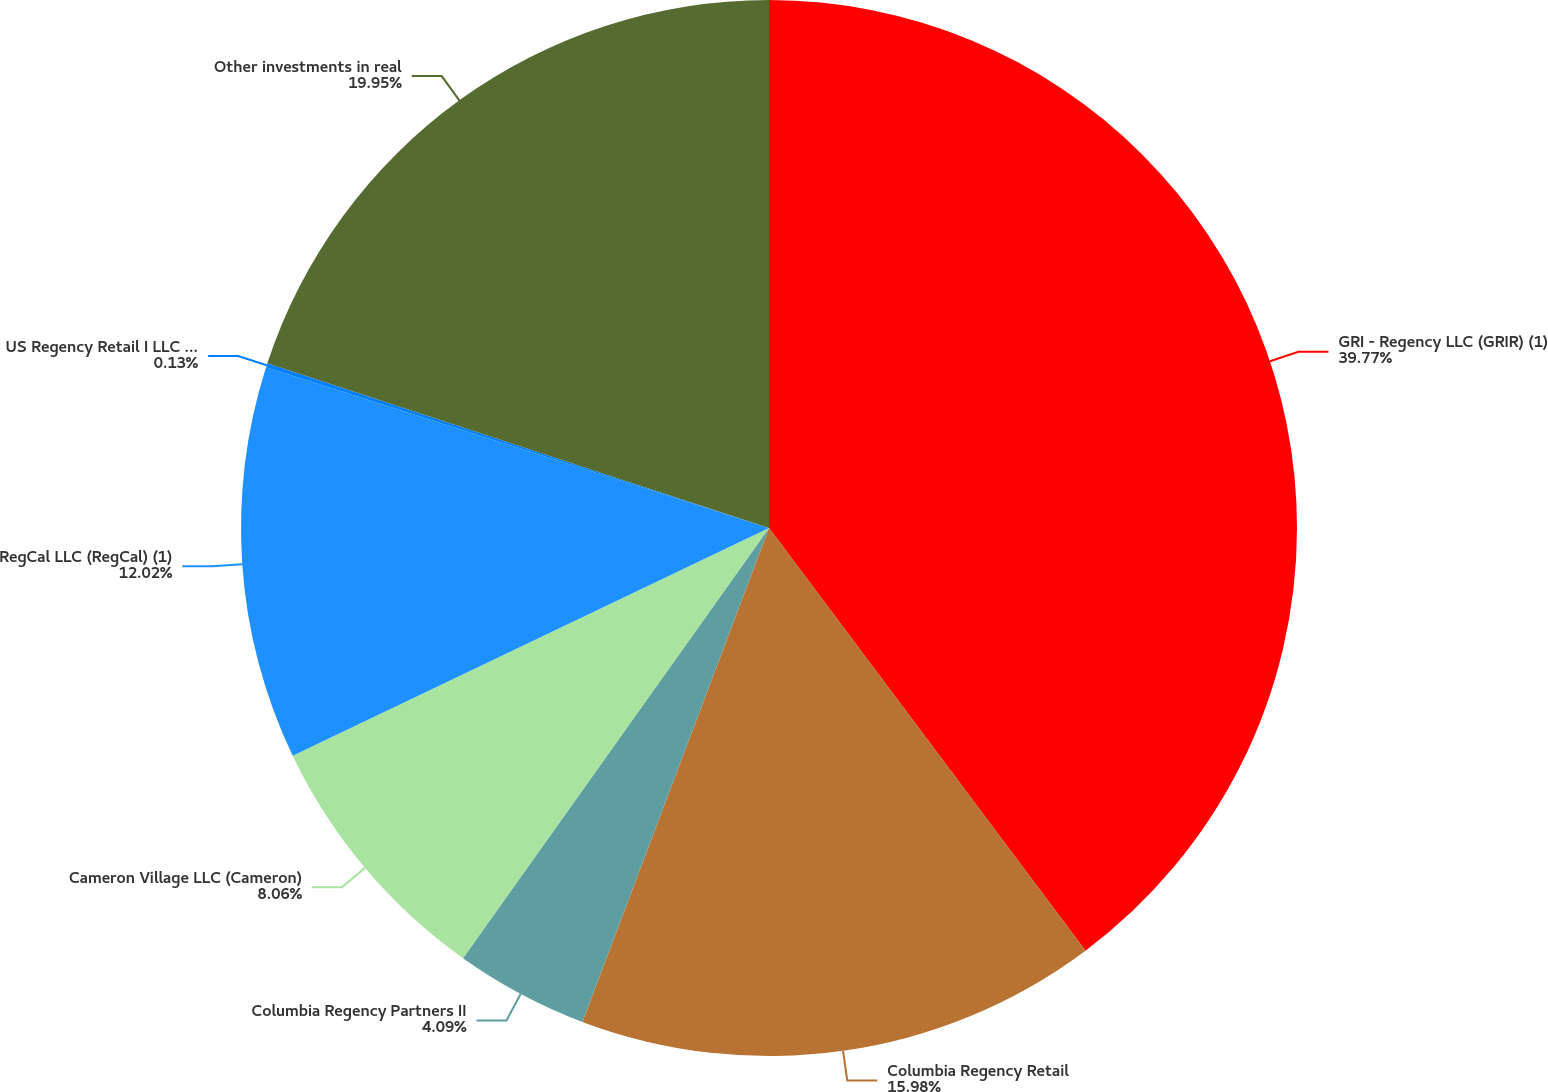Convert chart. <chart><loc_0><loc_0><loc_500><loc_500><pie_chart><fcel>GRI - Regency LLC (GRIR) (1)<fcel>Columbia Regency Retail<fcel>Columbia Regency Partners II<fcel>Cameron Village LLC (Cameron)<fcel>RegCal LLC (RegCal) (1)<fcel>US Regency Retail I LLC (USAA)<fcel>Other investments in real<nl><fcel>39.77%<fcel>15.98%<fcel>4.09%<fcel>8.06%<fcel>12.02%<fcel>0.13%<fcel>19.95%<nl></chart> 